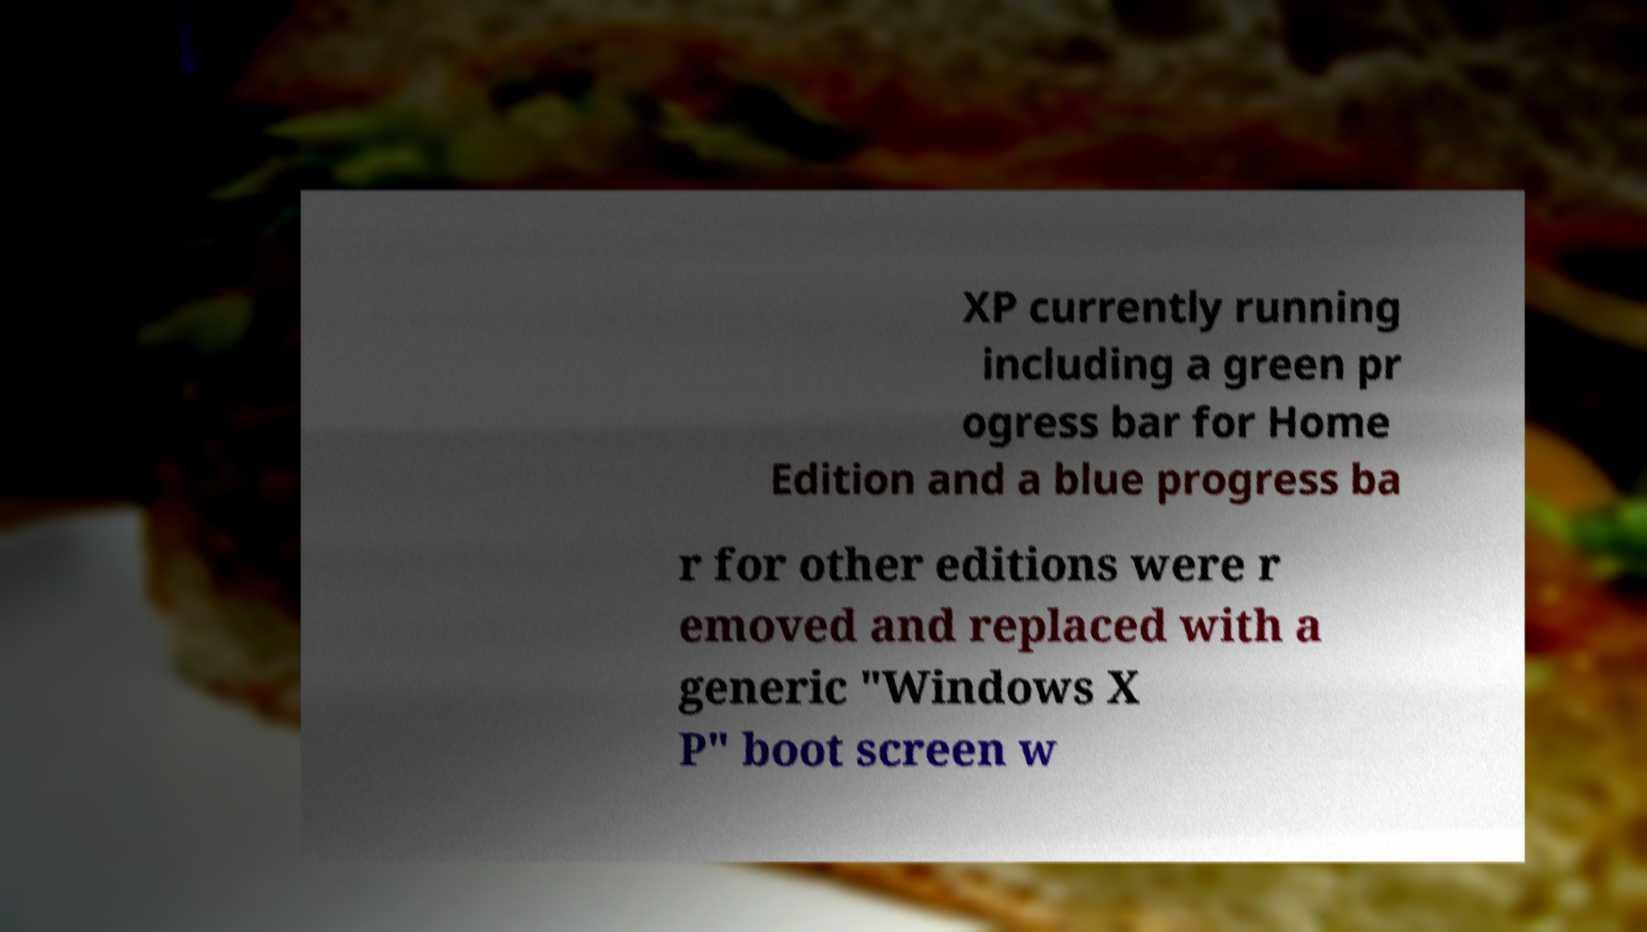Could you assist in decoding the text presented in this image and type it out clearly? XP currently running including a green pr ogress bar for Home Edition and a blue progress ba r for other editions were r emoved and replaced with a generic "Windows X P" boot screen w 